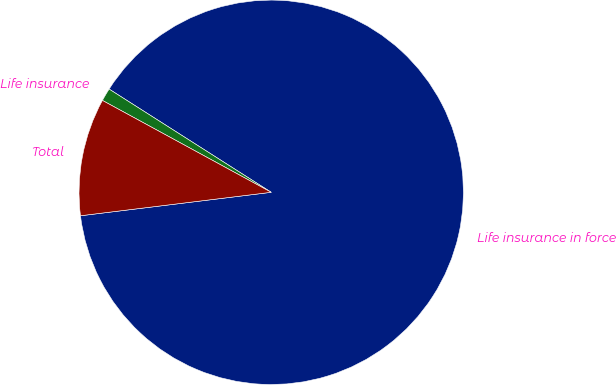Convert chart to OTSL. <chart><loc_0><loc_0><loc_500><loc_500><pie_chart><fcel>Life insurance in force<fcel>Life insurance<fcel>Total<nl><fcel>89.02%<fcel>1.09%<fcel>9.88%<nl></chart> 